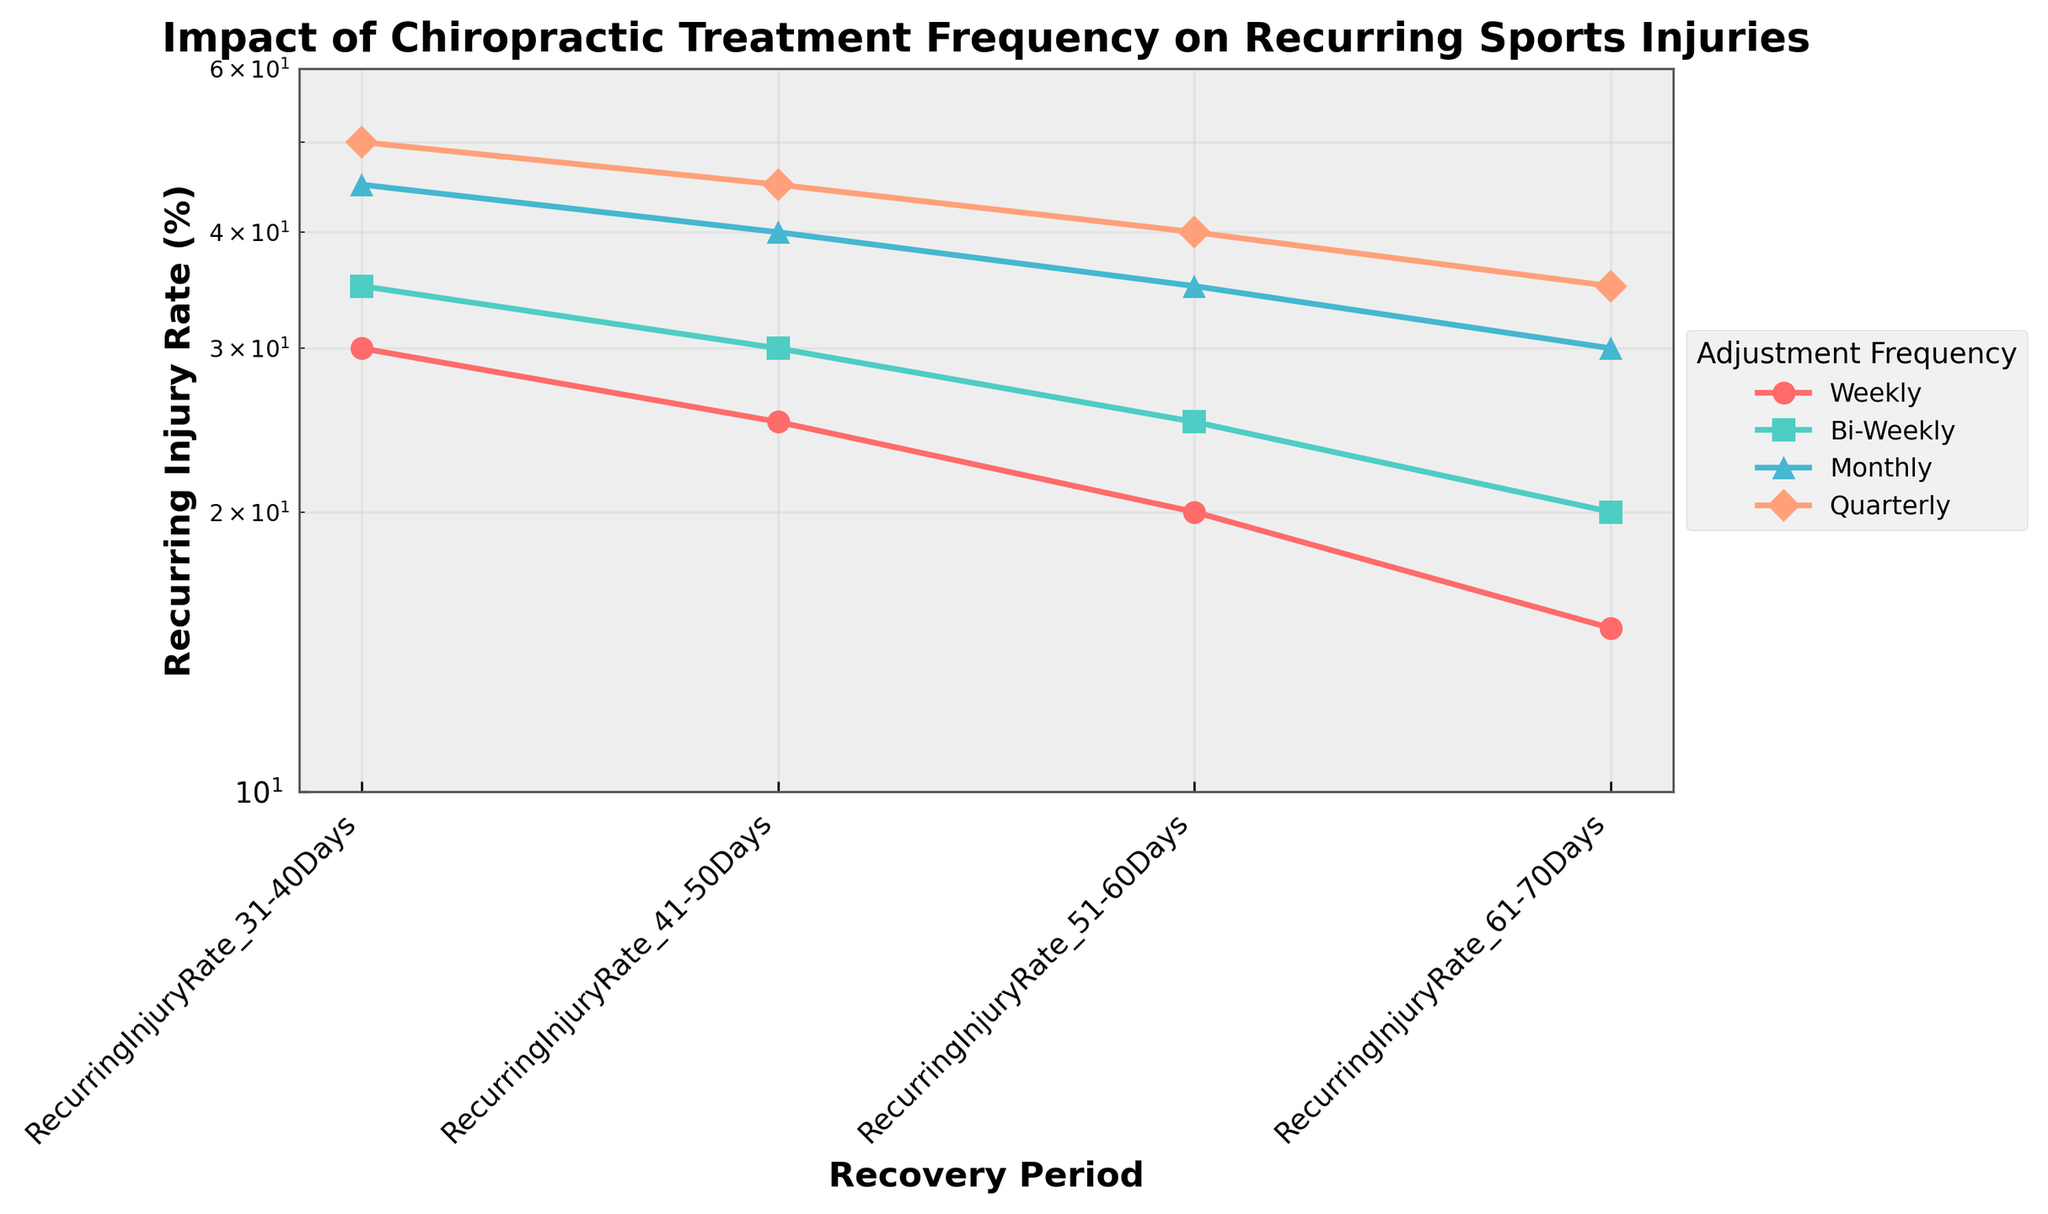What is the title of the figure? The title of the figure is displayed at the top. It reads: "Impact of Chiropractic Treatment Frequency on Recurring Sports Injuries".
Answer: Impact of Chiropractic Treatment Frequency on Recurring Sports Injuries Which chiropractic adjustment frequency shows the lowest recurring injury rate at the 31-40 days recovery period? The lowest recurring injury rate at the 31-40 days recovery period is represented by the line with the minimum y-value at that point. The frequency corresponding to this line is 'Weekly'.
Answer: Weekly What is the recurring injury rate for the Monthly frequency at the 51-60 days recovery period? Trace the line labeled 'Monthly' to the 51-60 days point on the x-axis, and read the corresponding y-value. It shows an injury rate of 35%.
Answer: 35% How does the Quarterly frequency compare to the Weekly frequency at the 61-70 days recovery period? Compare the y-values of the 'Quarterly' and 'Weekly' lines at the 61-70 days point on the x-axis. The 'Quarterly' frequency has a higher recurring injury rate (35%) than the 'Weekly' frequency (15%).
Answer: Quarterly is higher Which adjustment frequency has the steepest decline in recurring injury rate over the 31-70 days period? Evaluate the slopes of the lines. The 'Weekly' frequency shows the largest decrease in recurring injury rate from 30% to 15%, which is the steepest decline.
Answer: Weekly Summarize the general trend of recurring injury rates as the duration of chiropractic treatment increases. Across all frequencies, the recurring injury rate tends to decrease as the recovery period increases from 31-70 days. This is indicated by the downward trend of all lines in the plot.
Answer: Decreasing What is the average recurring injury rate for Bi-Weekly frequency across all periods? For Bi-Weekly frequency, sum the recurring injury rates across the periods (35 + 30 + 25 + 20) and divide by 4, giving: (35 + 30 + 25 + 20) / 4 = 27.5%.
Answer: 27.5% How many distinct chiropractic adjustment frequencies are represented in the figure? Count the number of unique labels in the legend. There are 4 distinct frequencies: 'Weekly', 'Bi-Weekly', 'Monthly', and 'Quarterly'.
Answer: 4 What's the recurring injury rate difference between Bi-Weekly and Quarterly frequencies at the 51-60 days period? Subtract the recurring injury rate of Bi-Weekly at 51-60 days (25%) from the Quarterly rate at that same period (40%). The difference is 40% - 25% = 15%.
Answer: 15% Which frequency shows the highest recurring injury rate at the 41-50 days period? Identify the highest point on the y-axis at the 41-50 days x-coordinate. The 'Quarterly' frequency line has the maximum value of 45%.
Answer: Quarterly 